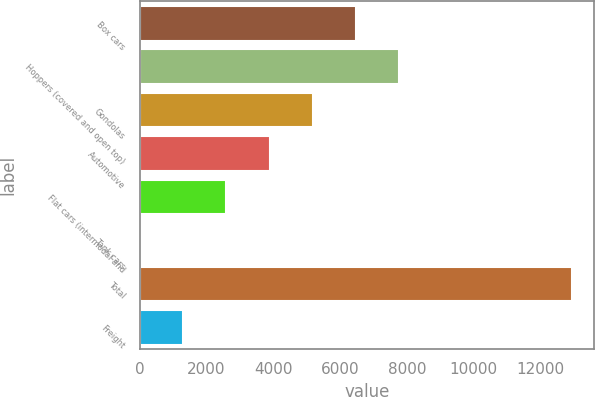Convert chart. <chart><loc_0><loc_0><loc_500><loc_500><bar_chart><fcel>Box cars<fcel>Hoppers (covered and open top)<fcel>Gondolas<fcel>Automotive<fcel>Flat cars (intermodal and<fcel>Tank cars<fcel>Total<fcel>Freight<nl><fcel>6478<fcel>7772.4<fcel>5183.6<fcel>3889.2<fcel>2594.8<fcel>6<fcel>12950<fcel>1300.4<nl></chart> 